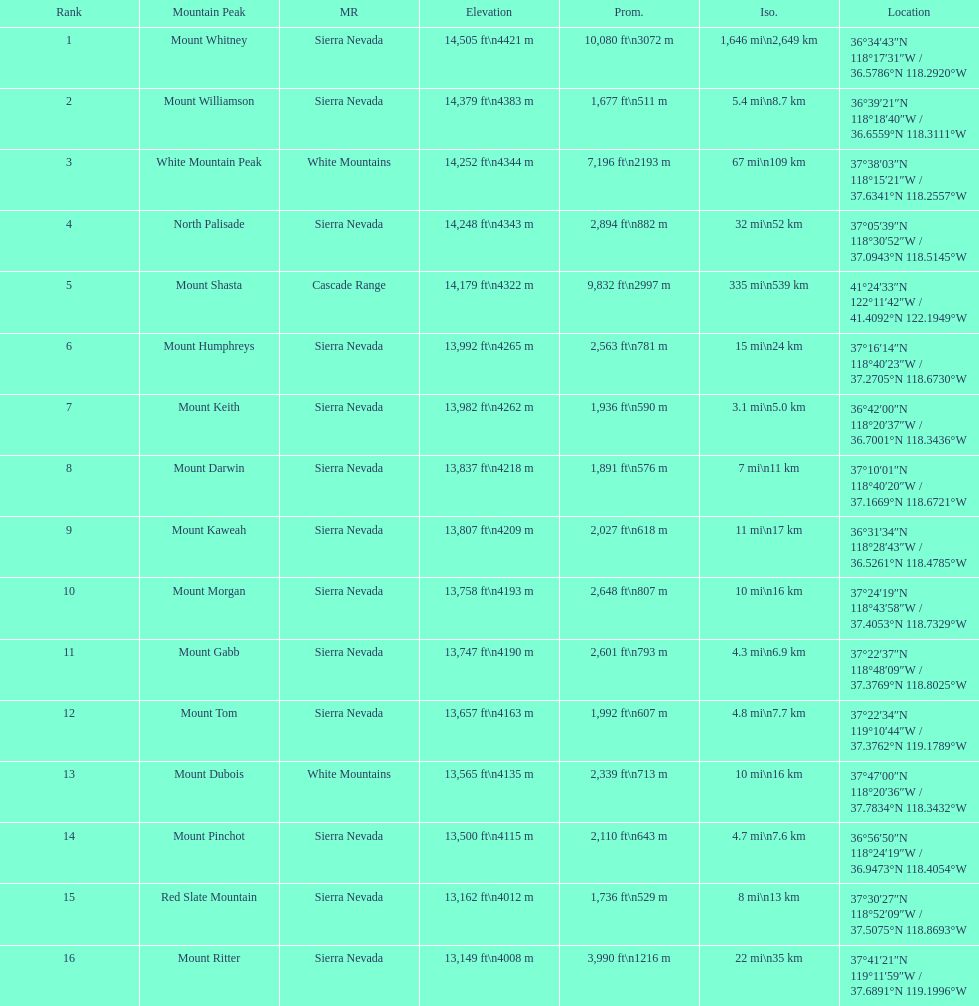What is the total elevation (in ft) of mount whitney? 14,505 ft. 